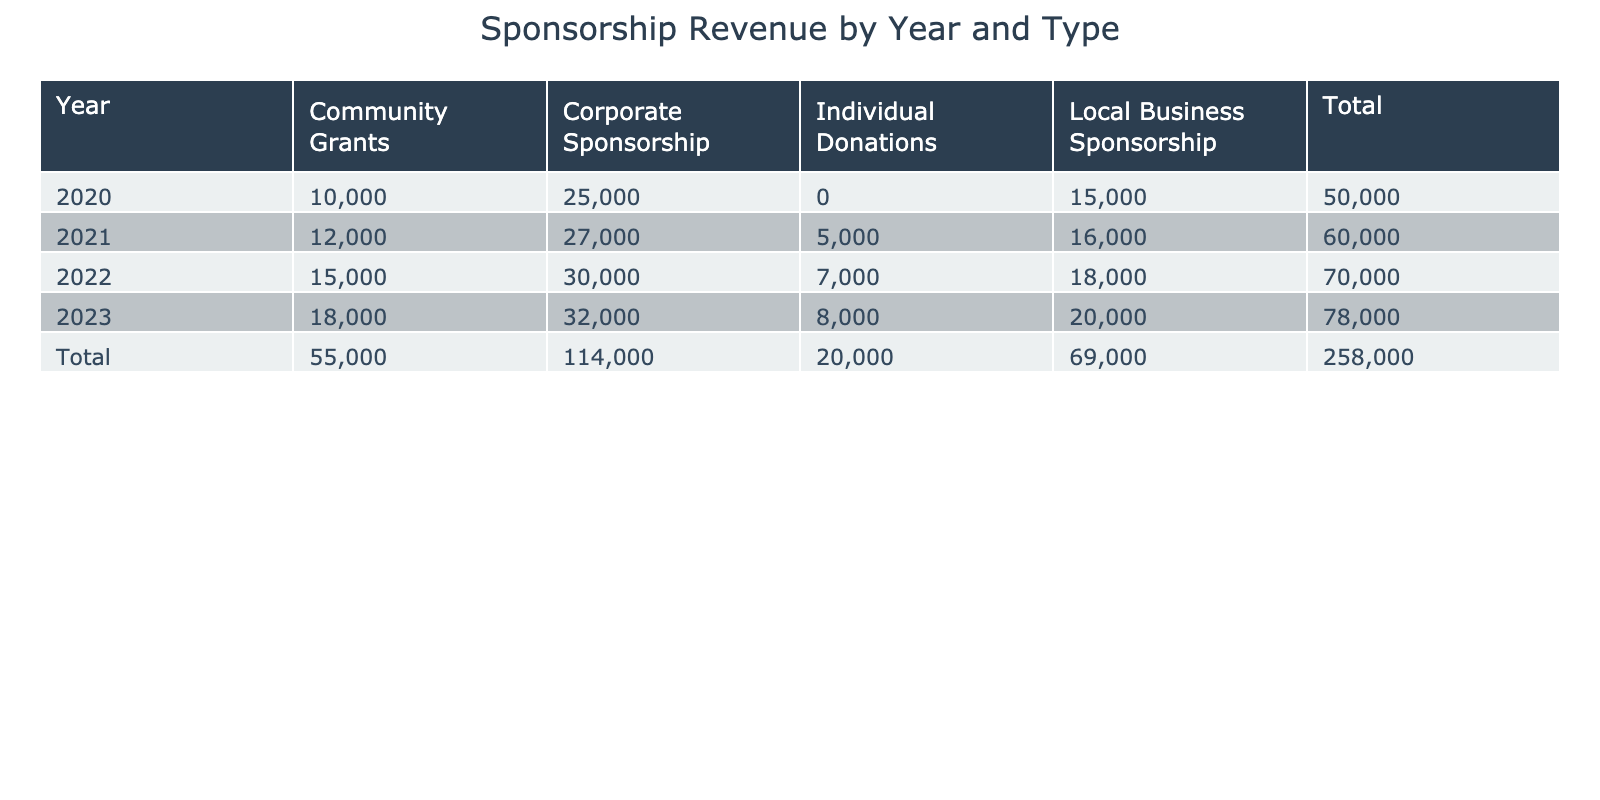What was the total sponsorship revenue for Grassroots Football Organizations in 2021? By looking at the table for the year 2021, I can sum the values in the "Total" column. The values for that year are $16,000 (Local Business), $27,000 (Corporate), $5,000 (Individual Donations), and $12,000 (Community Grants). Adding these gives: 16,000 + 27,000 + 5,000 + 12,000 = 60,000.
Answer: 60,000 Which type of sponsorship had the highest revenue in 2022? In the year 2022, I can check the values for each type of sponsorship. Local Business received $18,000, Corporate received $30,000, Individual Donations received $7,000, and Community Grants received $15,000. Among these, Corporate sponsorship with $30,000 is the highest.
Answer: Corporate Sponsorship Was there an increase in the total sponsorship revenue from 2020 to 2023? First, I need to find the totals for both years. In 2020, the total revenue is $15,000 (Local Business) + $25,000 (Corporate) + $10,000 (Community Grants) = $50,000. In 2023, the totals are $20,000 (Local Business) + $32,000 (Corporate) + $8,000 (Individual Donations) + $18,000 (Community Grants) = $78,000. The difference is $78,000 - $50,000 = $28,000, indicating an increase.
Answer: Yes What was the average revenue from Individual Donations over the four years? The revenues for Individual Donations across the years are: 0 (2020, no entry) + $5,000 (2021) + $7,000 (2022) + $8,000 (2023) = $20,000. Dividing by the three years that have values (2021, 2022, 2023): 20,000 / 3 = approximately 6,667.
Answer: 6,667 Did Community Grants ever surpass $15,000 in any year? Checking the values for Community Grants: In 2020, it was $10,000, in 2021 it was $12,000, in 2022 it was $15,000, and in 2023 it was $18,000. The value exceeded $15,000 in 2023, therefore the answer is yes.
Answer: Yes Which year had the lowest revenue from Local Business sponsorship? Checking the values for Local Business sponsorship: $15,000 (2020), $16,000 (2021), $18,000 (2022), and $20,000 (2023). The lowest is 2020 with $15,000.
Answer: 2020 What is the total revenue generated by Corporate Sponsorship over the years? The Corporate Sponsorship revenues are: $25,000 (2020), $27,000 (2021), $30,000 (2022), and $32,000 (2023). Adding these gives: 25,000 + 27,000 + 30,000 + 32,000 = 114,000.
Answer: 114,000 Which organization received the highest sponsorship revenue in a single year? Looking through the values provided, the highest revenue comes from GreenTech Solutions in 2023, with $32,000. Other organizations received lower amounts in their respective years.
Answer: GreenTech Solutions 